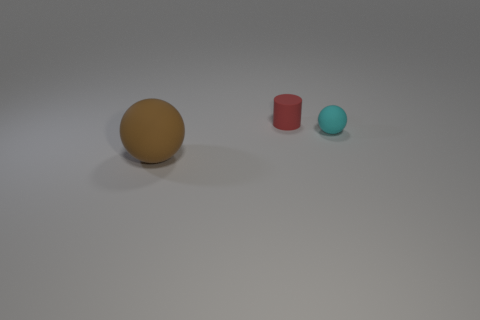What material is the small thing that is on the right side of the rubber cylinder?
Your response must be concise. Rubber. Is there a big brown object that has the same shape as the small cyan object?
Keep it short and to the point. Yes. How many other things are there of the same shape as the red thing?
Offer a very short reply. 0. There is a big brown object; is its shape the same as the small rubber object right of the red matte thing?
Offer a very short reply. Yes. There is another thing that is the same shape as the big thing; what is it made of?
Keep it short and to the point. Rubber. How many big objects are purple blocks or red matte objects?
Make the answer very short. 0. Are there fewer small cyan things that are to the left of the red rubber cylinder than matte things behind the cyan rubber thing?
Provide a short and direct response. Yes. What number of things are gray blocks or matte balls?
Make the answer very short. 2. There is a tiny red matte cylinder; what number of objects are behind it?
Offer a terse response. 0. Does the small cylinder have the same color as the small sphere?
Your answer should be compact. No. 